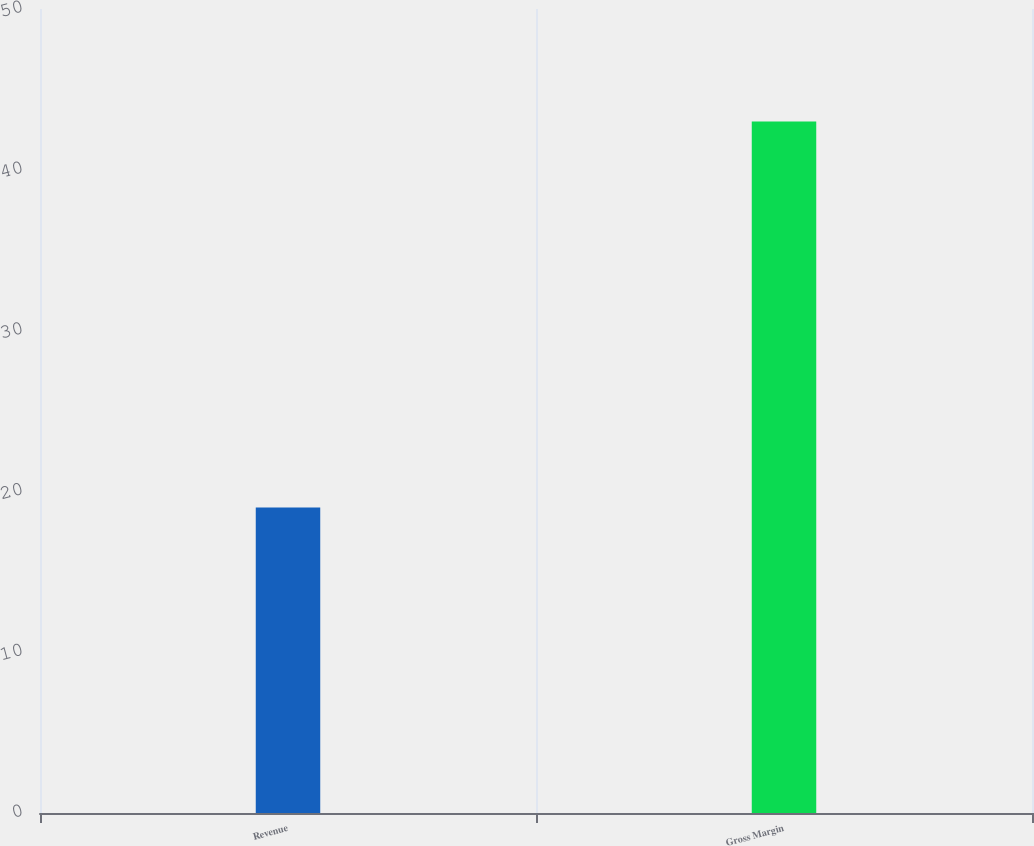<chart> <loc_0><loc_0><loc_500><loc_500><bar_chart><fcel>Revenue<fcel>Gross Margin<nl><fcel>19<fcel>43<nl></chart> 